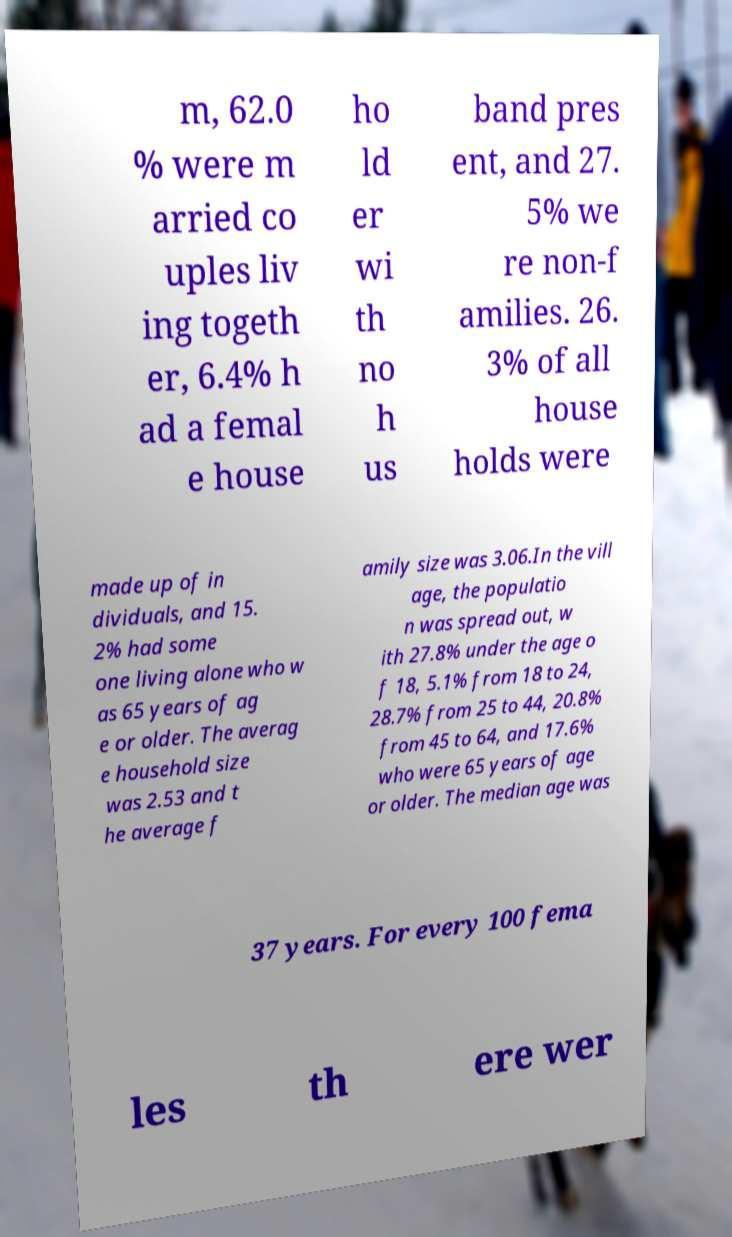Please read and relay the text visible in this image. What does it say? m, 62.0 % were m arried co uples liv ing togeth er, 6.4% h ad a femal e house ho ld er wi th no h us band pres ent, and 27. 5% we re non-f amilies. 26. 3% of all house holds were made up of in dividuals, and 15. 2% had some one living alone who w as 65 years of ag e or older. The averag e household size was 2.53 and t he average f amily size was 3.06.In the vill age, the populatio n was spread out, w ith 27.8% under the age o f 18, 5.1% from 18 to 24, 28.7% from 25 to 44, 20.8% from 45 to 64, and 17.6% who were 65 years of age or older. The median age was 37 years. For every 100 fema les th ere wer 